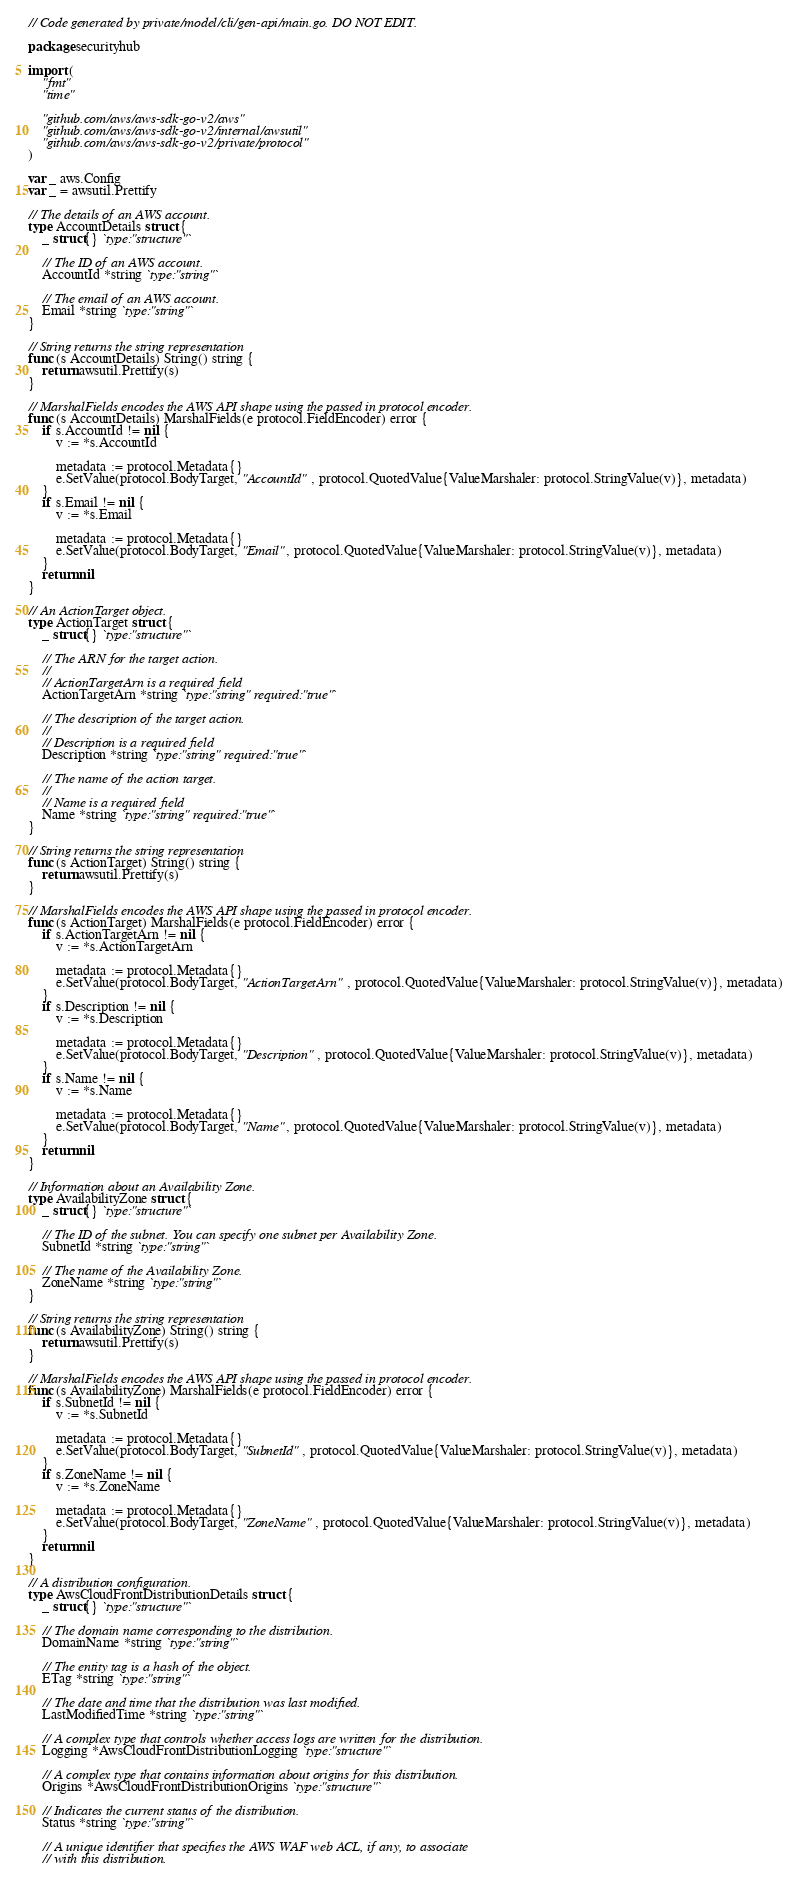<code> <loc_0><loc_0><loc_500><loc_500><_Go_>// Code generated by private/model/cli/gen-api/main.go. DO NOT EDIT.

package securityhub

import (
	"fmt"
	"time"

	"github.com/aws/aws-sdk-go-v2/aws"
	"github.com/aws/aws-sdk-go-v2/internal/awsutil"
	"github.com/aws/aws-sdk-go-v2/private/protocol"
)

var _ aws.Config
var _ = awsutil.Prettify

// The details of an AWS account.
type AccountDetails struct {
	_ struct{} `type:"structure"`

	// The ID of an AWS account.
	AccountId *string `type:"string"`

	// The email of an AWS account.
	Email *string `type:"string"`
}

// String returns the string representation
func (s AccountDetails) String() string {
	return awsutil.Prettify(s)
}

// MarshalFields encodes the AWS API shape using the passed in protocol encoder.
func (s AccountDetails) MarshalFields(e protocol.FieldEncoder) error {
	if s.AccountId != nil {
		v := *s.AccountId

		metadata := protocol.Metadata{}
		e.SetValue(protocol.BodyTarget, "AccountId", protocol.QuotedValue{ValueMarshaler: protocol.StringValue(v)}, metadata)
	}
	if s.Email != nil {
		v := *s.Email

		metadata := protocol.Metadata{}
		e.SetValue(protocol.BodyTarget, "Email", protocol.QuotedValue{ValueMarshaler: protocol.StringValue(v)}, metadata)
	}
	return nil
}

// An ActionTarget object.
type ActionTarget struct {
	_ struct{} `type:"structure"`

	// The ARN for the target action.
	//
	// ActionTargetArn is a required field
	ActionTargetArn *string `type:"string" required:"true"`

	// The description of the target action.
	//
	// Description is a required field
	Description *string `type:"string" required:"true"`

	// The name of the action target.
	//
	// Name is a required field
	Name *string `type:"string" required:"true"`
}

// String returns the string representation
func (s ActionTarget) String() string {
	return awsutil.Prettify(s)
}

// MarshalFields encodes the AWS API shape using the passed in protocol encoder.
func (s ActionTarget) MarshalFields(e protocol.FieldEncoder) error {
	if s.ActionTargetArn != nil {
		v := *s.ActionTargetArn

		metadata := protocol.Metadata{}
		e.SetValue(protocol.BodyTarget, "ActionTargetArn", protocol.QuotedValue{ValueMarshaler: protocol.StringValue(v)}, metadata)
	}
	if s.Description != nil {
		v := *s.Description

		metadata := protocol.Metadata{}
		e.SetValue(protocol.BodyTarget, "Description", protocol.QuotedValue{ValueMarshaler: protocol.StringValue(v)}, metadata)
	}
	if s.Name != nil {
		v := *s.Name

		metadata := protocol.Metadata{}
		e.SetValue(protocol.BodyTarget, "Name", protocol.QuotedValue{ValueMarshaler: protocol.StringValue(v)}, metadata)
	}
	return nil
}

// Information about an Availability Zone.
type AvailabilityZone struct {
	_ struct{} `type:"structure"`

	// The ID of the subnet. You can specify one subnet per Availability Zone.
	SubnetId *string `type:"string"`

	// The name of the Availability Zone.
	ZoneName *string `type:"string"`
}

// String returns the string representation
func (s AvailabilityZone) String() string {
	return awsutil.Prettify(s)
}

// MarshalFields encodes the AWS API shape using the passed in protocol encoder.
func (s AvailabilityZone) MarshalFields(e protocol.FieldEncoder) error {
	if s.SubnetId != nil {
		v := *s.SubnetId

		metadata := protocol.Metadata{}
		e.SetValue(protocol.BodyTarget, "SubnetId", protocol.QuotedValue{ValueMarshaler: protocol.StringValue(v)}, metadata)
	}
	if s.ZoneName != nil {
		v := *s.ZoneName

		metadata := protocol.Metadata{}
		e.SetValue(protocol.BodyTarget, "ZoneName", protocol.QuotedValue{ValueMarshaler: protocol.StringValue(v)}, metadata)
	}
	return nil
}

// A distribution configuration.
type AwsCloudFrontDistributionDetails struct {
	_ struct{} `type:"structure"`

	// The domain name corresponding to the distribution.
	DomainName *string `type:"string"`

	// The entity tag is a hash of the object.
	ETag *string `type:"string"`

	// The date and time that the distribution was last modified.
	LastModifiedTime *string `type:"string"`

	// A complex type that controls whether access logs are written for the distribution.
	Logging *AwsCloudFrontDistributionLogging `type:"structure"`

	// A complex type that contains information about origins for this distribution.
	Origins *AwsCloudFrontDistributionOrigins `type:"structure"`

	// Indicates the current status of the distribution.
	Status *string `type:"string"`

	// A unique identifier that specifies the AWS WAF web ACL, if any, to associate
	// with this distribution.</code> 